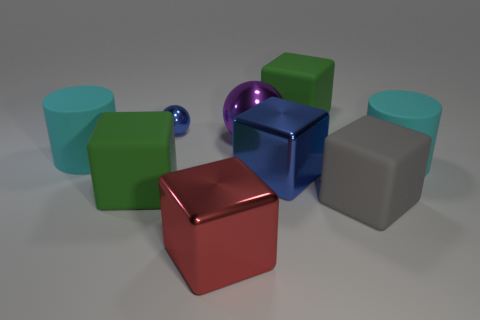Subtract all green blocks. How many blocks are left? 3 Add 1 tiny green balls. How many objects exist? 10 Subtract all blue balls. How many balls are left? 1 Subtract all cylinders. How many objects are left? 7 Subtract 2 spheres. How many spheres are left? 0 Add 4 blue things. How many blue things exist? 6 Subtract 1 green cubes. How many objects are left? 8 Subtract all purple balls. Subtract all yellow cubes. How many balls are left? 1 Subtract all cyan balls. How many yellow cylinders are left? 0 Subtract all blue cubes. Subtract all large cubes. How many objects are left? 3 